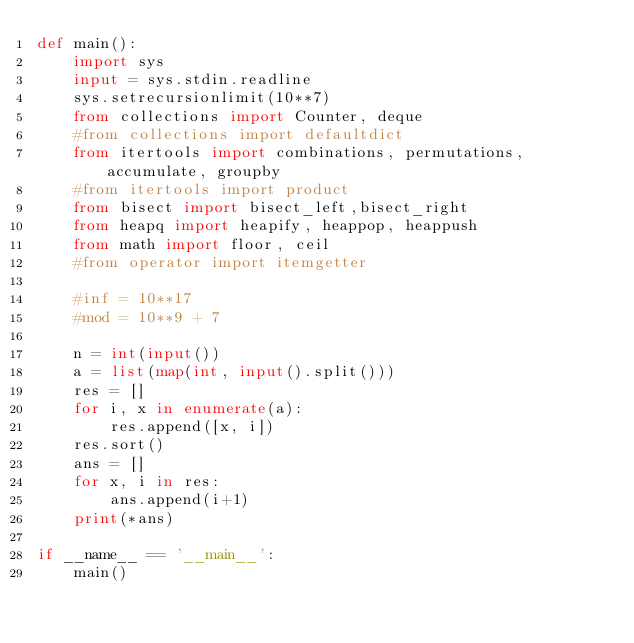Convert code to text. <code><loc_0><loc_0><loc_500><loc_500><_Python_>def main():
    import sys
    input = sys.stdin.readline
    sys.setrecursionlimit(10**7)
    from collections import Counter, deque
    #from collections import defaultdict
    from itertools import combinations, permutations, accumulate, groupby
    #from itertools import product
    from bisect import bisect_left,bisect_right
    from heapq import heapify, heappop, heappush
    from math import floor, ceil
    #from operator import itemgetter

    #inf = 10**17
    #mod = 10**9 + 7

    n = int(input())
    a = list(map(int, input().split()))
    res = []
    for i, x in enumerate(a):
        res.append([x, i])
    res.sort()
    ans = []
    for x, i in res:
        ans.append(i+1)
    print(*ans)

if __name__ == '__main__':
    main()</code> 